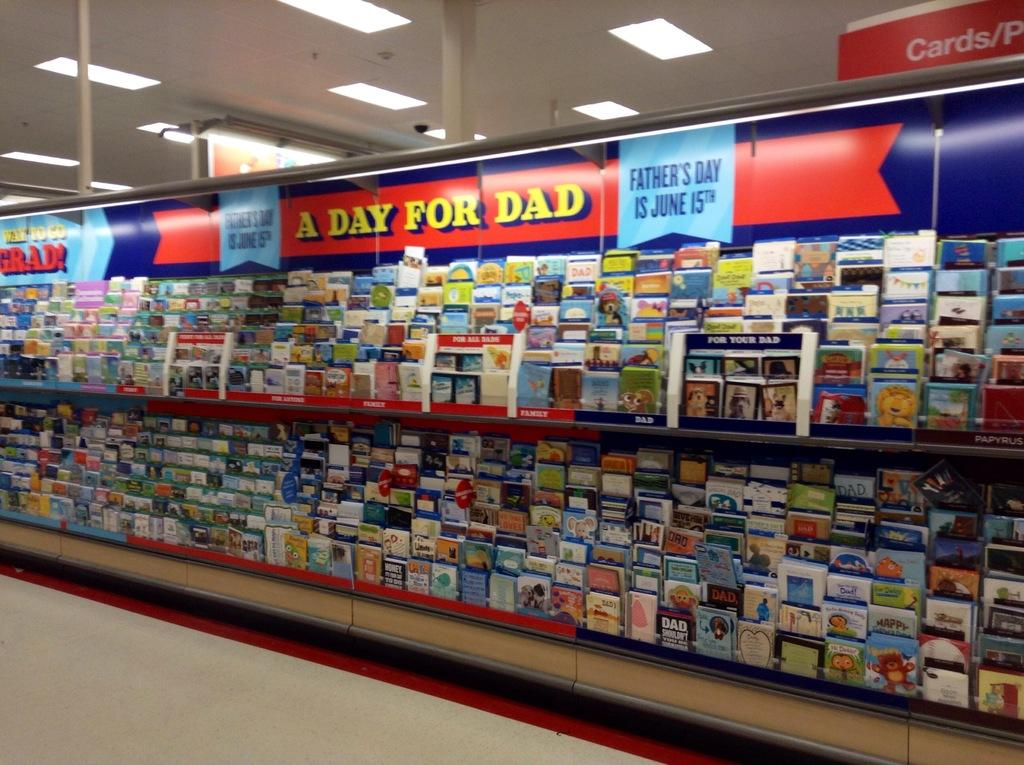<image>
Create a compact narrative representing the image presented. a greeting card display with a banner that says A DAY FOR DAD on it. 